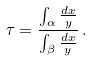<formula> <loc_0><loc_0><loc_500><loc_500>\tau = \frac { \int _ { \alpha } \frac { d x } { y } } { \int _ { \beta } \frac { d x } { y } } \, .</formula> 